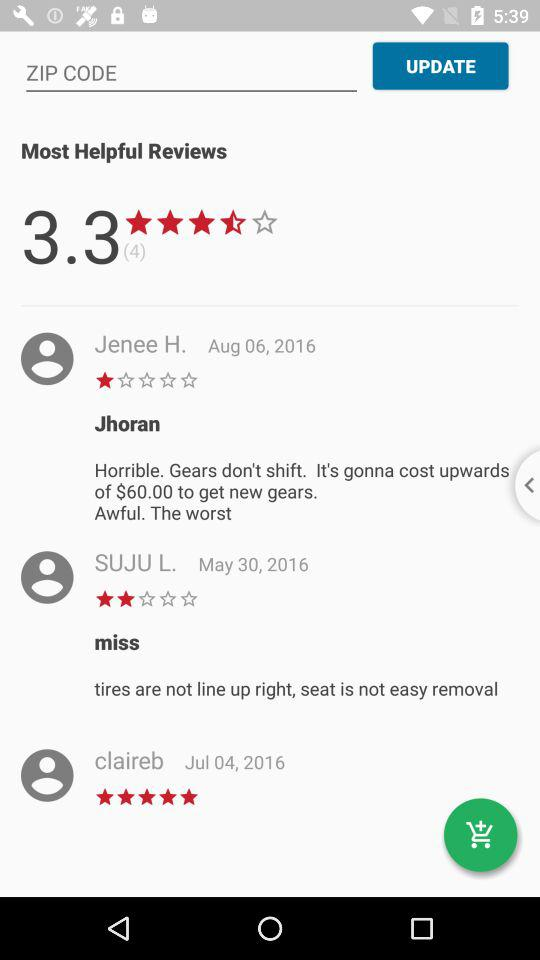On which date did Suju L. update the review? Suju L. updated the review on May 30, 2016. 